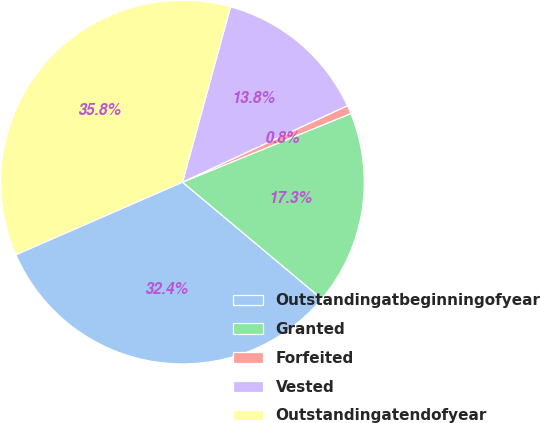Convert chart. <chart><loc_0><loc_0><loc_500><loc_500><pie_chart><fcel>Outstandingatbeginningofyear<fcel>Granted<fcel>Forfeited<fcel>Vested<fcel>Outstandingatendofyear<nl><fcel>32.36%<fcel>17.26%<fcel>0.75%<fcel>13.83%<fcel>35.79%<nl></chart> 